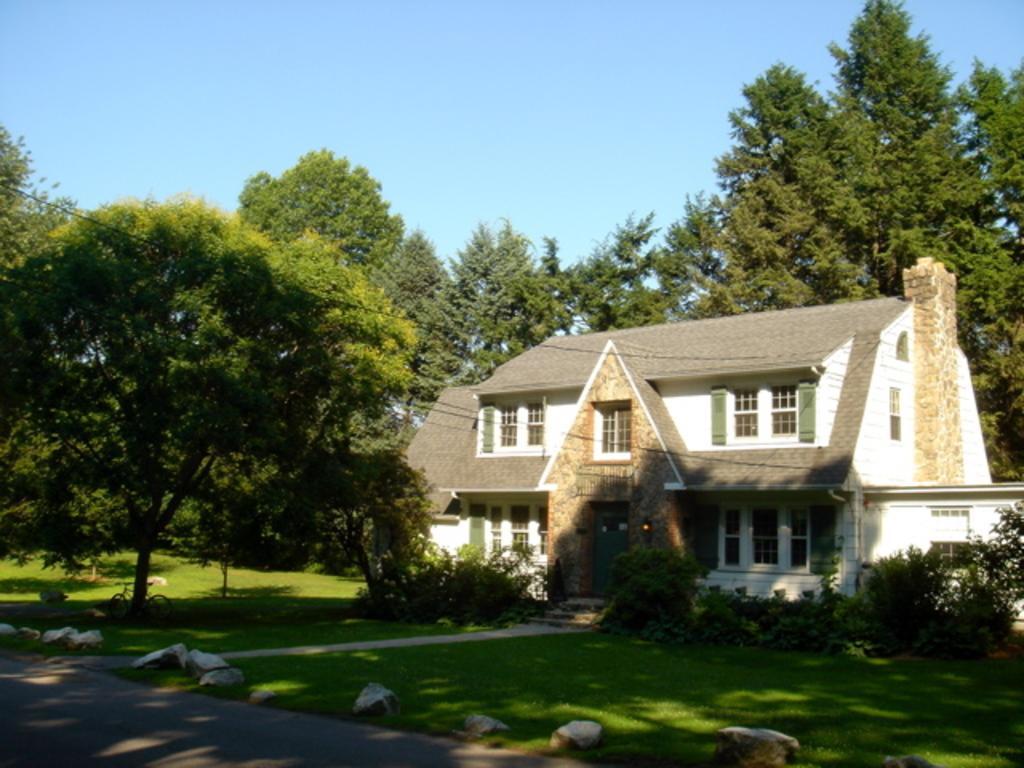Describe this image in one or two sentences. In this picture we can see a building, trees, bicycle, some stones and we can see sky in the background. 